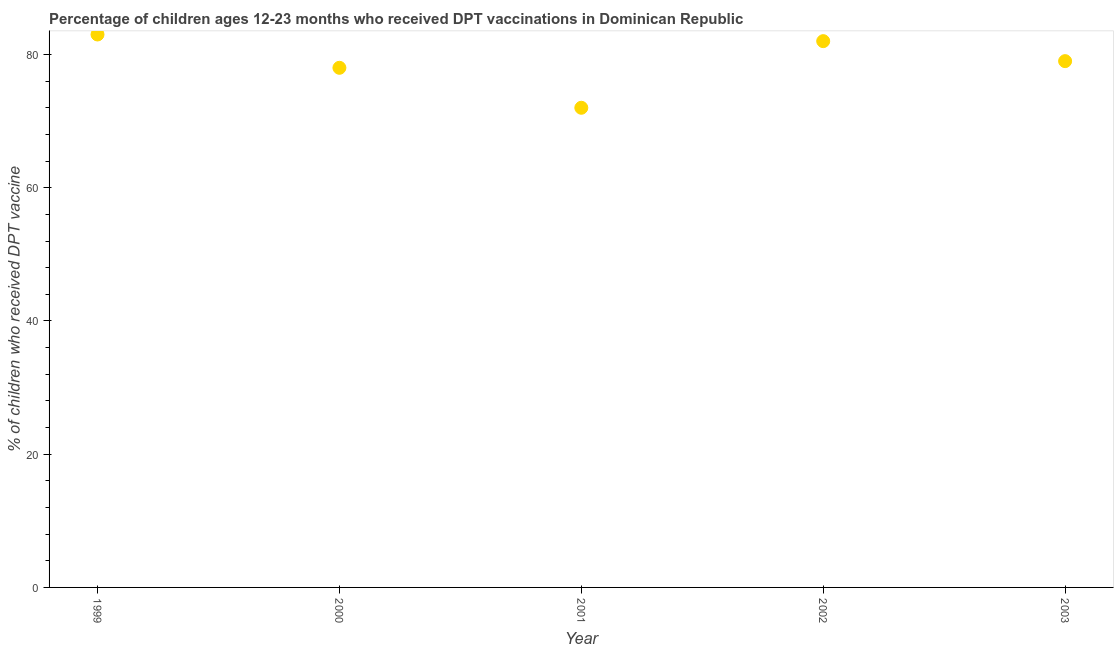What is the percentage of children who received dpt vaccine in 2002?
Make the answer very short. 82. Across all years, what is the maximum percentage of children who received dpt vaccine?
Ensure brevity in your answer.  83. Across all years, what is the minimum percentage of children who received dpt vaccine?
Provide a succinct answer. 72. In which year was the percentage of children who received dpt vaccine maximum?
Your answer should be very brief. 1999. In which year was the percentage of children who received dpt vaccine minimum?
Keep it short and to the point. 2001. What is the sum of the percentage of children who received dpt vaccine?
Ensure brevity in your answer.  394. What is the difference between the percentage of children who received dpt vaccine in 2000 and 2001?
Ensure brevity in your answer.  6. What is the average percentage of children who received dpt vaccine per year?
Keep it short and to the point. 78.8. What is the median percentage of children who received dpt vaccine?
Provide a short and direct response. 79. In how many years, is the percentage of children who received dpt vaccine greater than 20 %?
Keep it short and to the point. 5. What is the ratio of the percentage of children who received dpt vaccine in 2000 to that in 2002?
Your answer should be compact. 0.95. What is the difference between the highest and the second highest percentage of children who received dpt vaccine?
Provide a short and direct response. 1. What is the difference between the highest and the lowest percentage of children who received dpt vaccine?
Your response must be concise. 11. In how many years, is the percentage of children who received dpt vaccine greater than the average percentage of children who received dpt vaccine taken over all years?
Provide a succinct answer. 3. Does the percentage of children who received dpt vaccine monotonically increase over the years?
Provide a succinct answer. No. How many dotlines are there?
Your answer should be compact. 1. What is the difference between two consecutive major ticks on the Y-axis?
Your answer should be very brief. 20. Are the values on the major ticks of Y-axis written in scientific E-notation?
Provide a short and direct response. No. Does the graph contain grids?
Offer a very short reply. No. What is the title of the graph?
Provide a succinct answer. Percentage of children ages 12-23 months who received DPT vaccinations in Dominican Republic. What is the label or title of the Y-axis?
Keep it short and to the point. % of children who received DPT vaccine. What is the % of children who received DPT vaccine in 2001?
Give a very brief answer. 72. What is the % of children who received DPT vaccine in 2003?
Keep it short and to the point. 79. What is the difference between the % of children who received DPT vaccine in 2000 and 2001?
Offer a terse response. 6. What is the difference between the % of children who received DPT vaccine in 2000 and 2003?
Keep it short and to the point. -1. What is the difference between the % of children who received DPT vaccine in 2001 and 2003?
Your answer should be very brief. -7. What is the difference between the % of children who received DPT vaccine in 2002 and 2003?
Your response must be concise. 3. What is the ratio of the % of children who received DPT vaccine in 1999 to that in 2000?
Keep it short and to the point. 1.06. What is the ratio of the % of children who received DPT vaccine in 1999 to that in 2001?
Your answer should be very brief. 1.15. What is the ratio of the % of children who received DPT vaccine in 1999 to that in 2002?
Provide a succinct answer. 1.01. What is the ratio of the % of children who received DPT vaccine in 1999 to that in 2003?
Give a very brief answer. 1.05. What is the ratio of the % of children who received DPT vaccine in 2000 to that in 2001?
Your answer should be compact. 1.08. What is the ratio of the % of children who received DPT vaccine in 2000 to that in 2002?
Ensure brevity in your answer.  0.95. What is the ratio of the % of children who received DPT vaccine in 2000 to that in 2003?
Ensure brevity in your answer.  0.99. What is the ratio of the % of children who received DPT vaccine in 2001 to that in 2002?
Offer a terse response. 0.88. What is the ratio of the % of children who received DPT vaccine in 2001 to that in 2003?
Provide a succinct answer. 0.91. What is the ratio of the % of children who received DPT vaccine in 2002 to that in 2003?
Give a very brief answer. 1.04. 